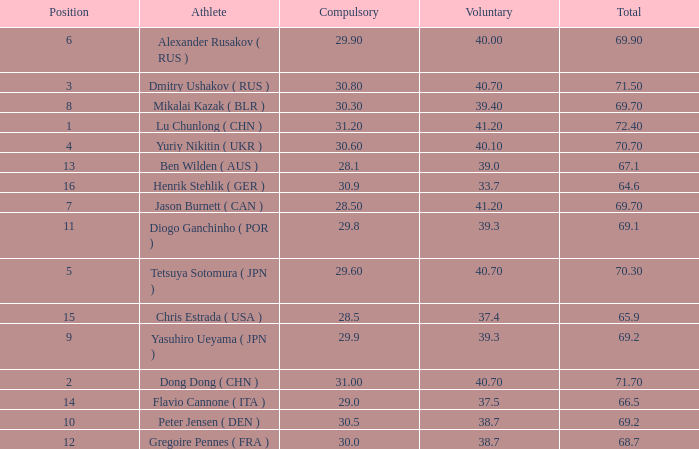What's the total compulsory when the total is more than 69.2 and the voluntary is 38.7? 0.0. 